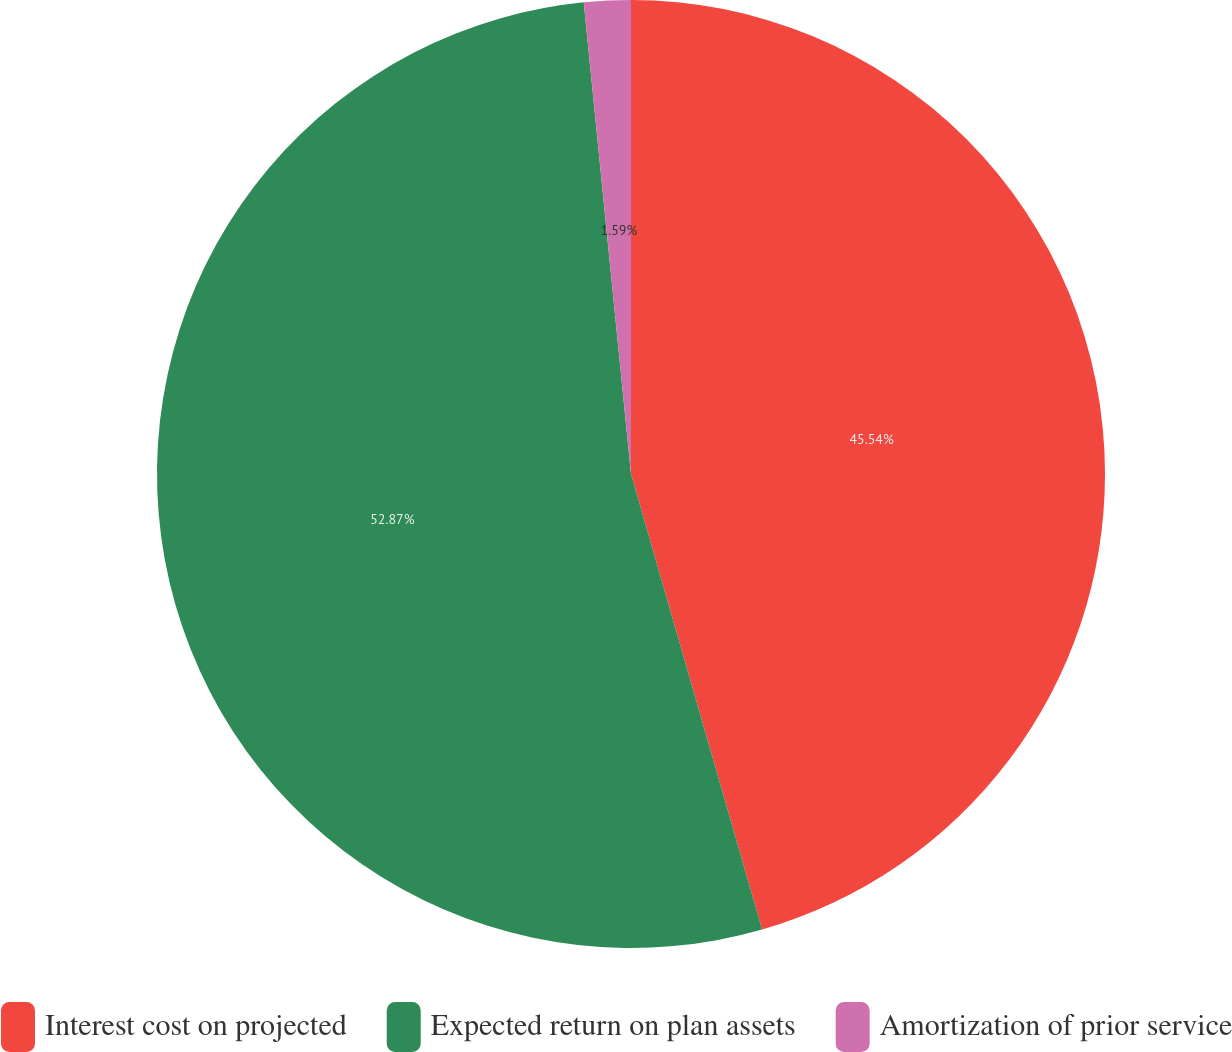Convert chart. <chart><loc_0><loc_0><loc_500><loc_500><pie_chart><fcel>Interest cost on projected<fcel>Expected return on plan assets<fcel>Amortization of prior service<nl><fcel>45.54%<fcel>52.87%<fcel>1.59%<nl></chart> 